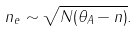Convert formula to latex. <formula><loc_0><loc_0><loc_500><loc_500>n _ { e } \sim \sqrt { N ( \theta _ { A } - n ) } .</formula> 